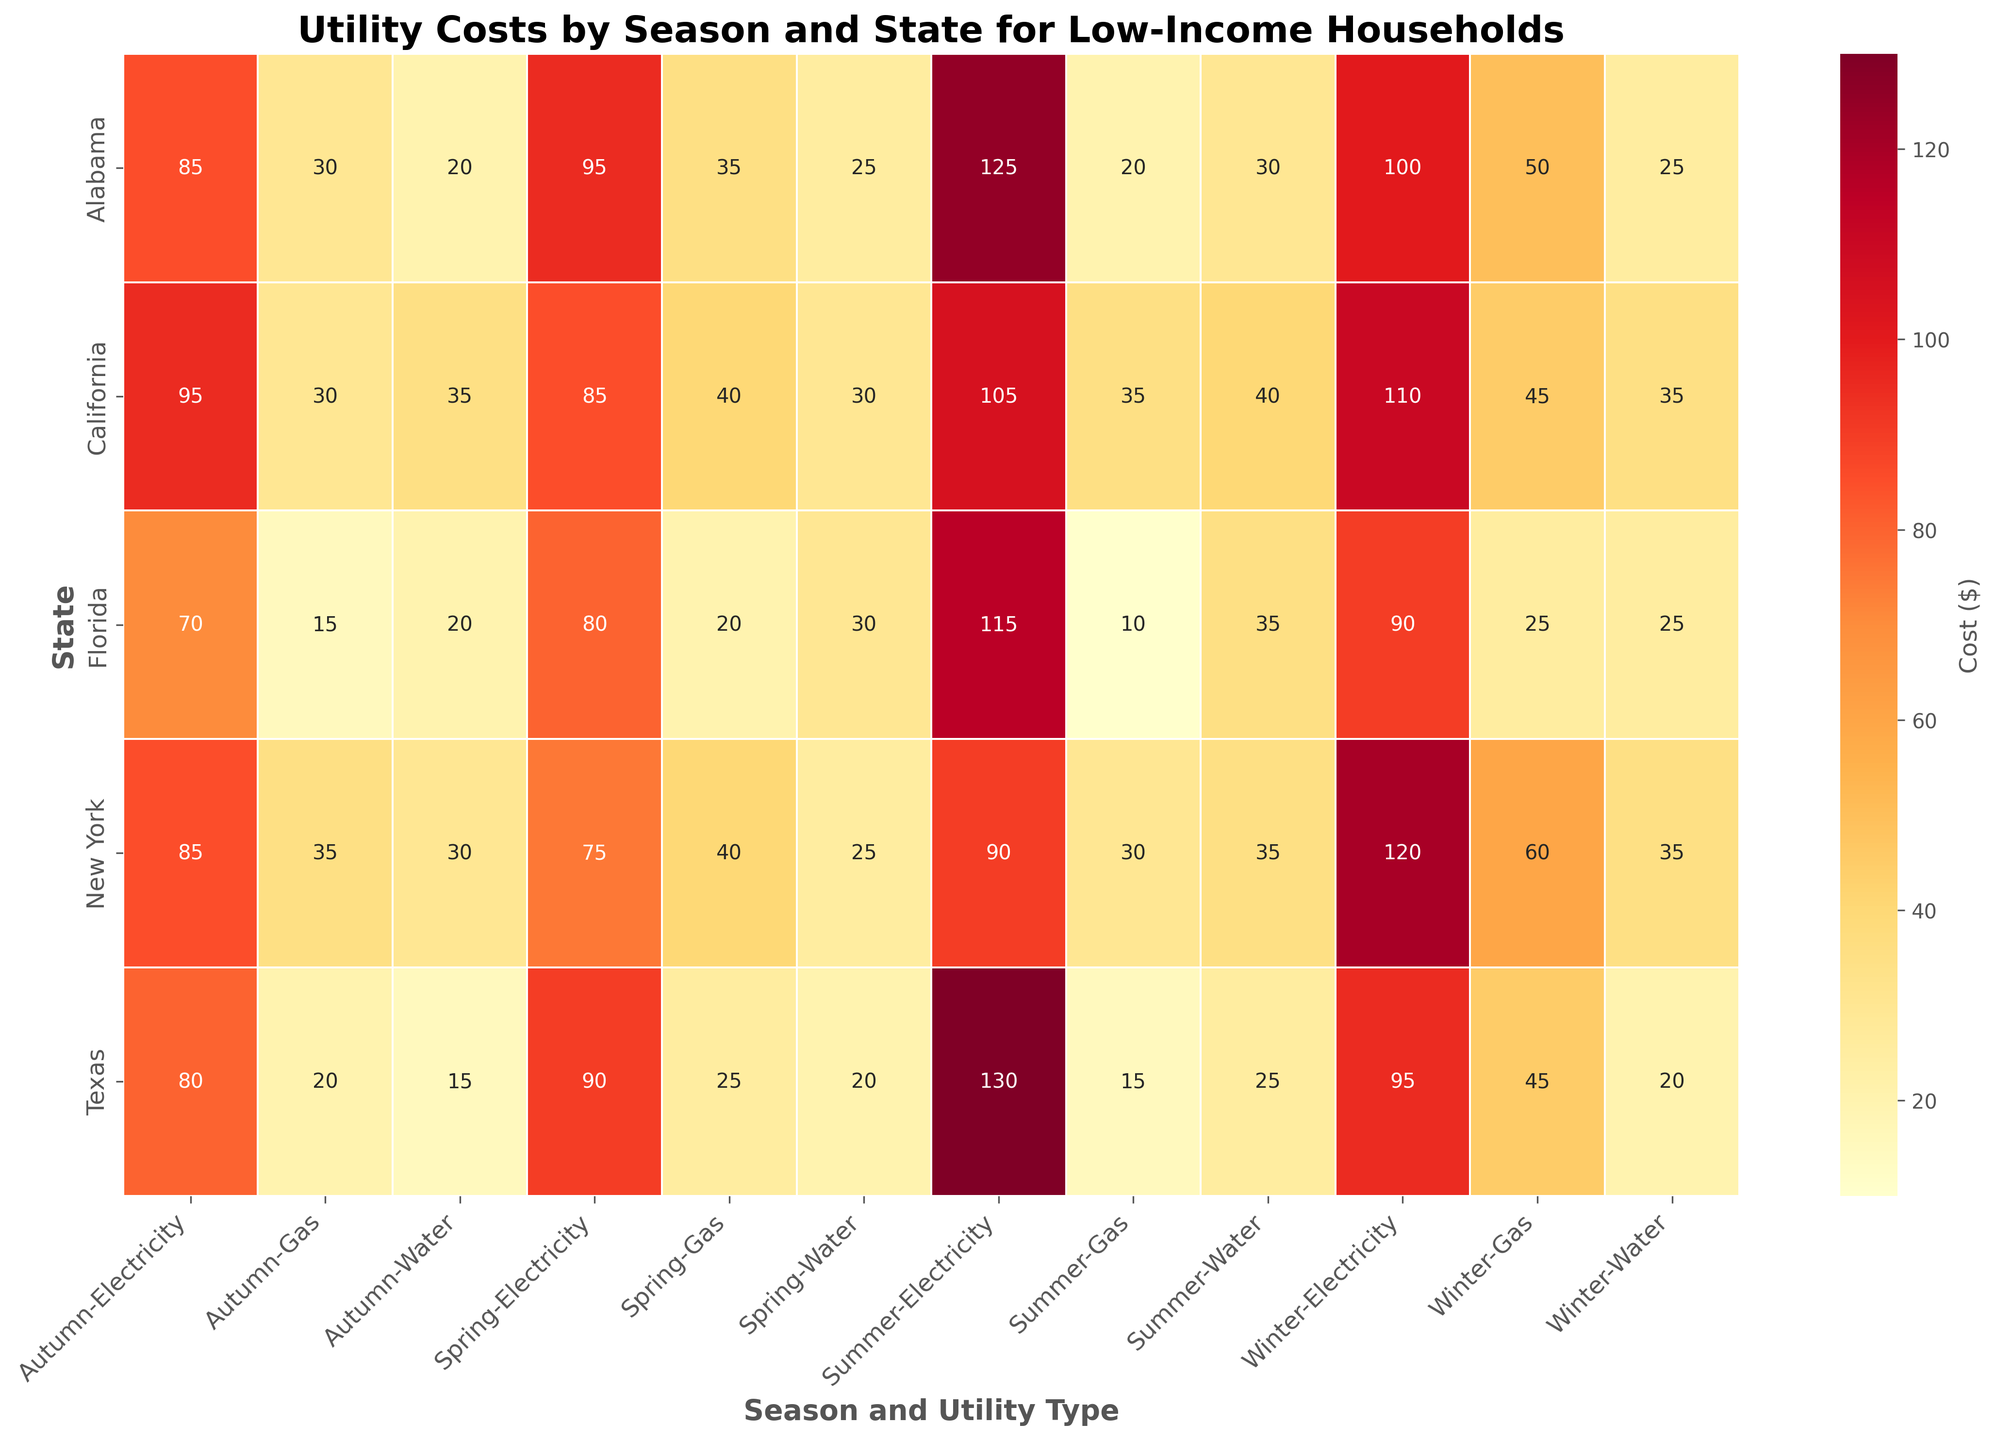What's the total utility cost for Alabama in the winter? Look at the intersection of Alabama and the Winter columns for all utility types (Electricity, Gas, Water). Sum these values: 100 (Electricity) + 50 (Gas) + 25 (Water) = 175.
Answer: 175 Which season has the highest electricity cost in Texas? Check the intersection of Texas and the four seasons for Electricity. Spring: 90, Summer: 130, Autumn: 80, Winter: 95. Summer has the highest electricity cost.
Answer: Summer Is the gas cost higher in New York or Florida during autumn? Compare the values at the intersection of Autumn and Gas for New York and Florida. New York: 35, Florida: 15. New York has the higher gas cost.
Answer: New York What's the average utility cost for Water across all seasons in California? Extract the Water costs for California in all seasons: 30 (Spring), 40 (Summer), 35 (Autumn), 35 (Winter). Average = (30 + 40 + 35 + 35) / 4 = 35.
Answer: 35 Which state has the lowest summer gas cost? Find the minimum value for Gas in Summer across all states. Alabama: 20, California: 35, Texas: 15, New York: 30, Florida: 10. Florida has the lowest summer gas cost.
Answer: Florida In which season is the utility cost for electricity and water combined highest in New York? Sum the electricity and water costs for each season in New York. 
- Spring: 75 + 25 = 100
- Summer: 90 + 35 = 125
- Autumn: 85 + 30 = 115
- Winter: 120 + 35 = 155
Winter has the highest combined cost.
Answer: Winter How much more does it cost for gas in Texas in the winter than in the summer? Subtract the summer gas cost from the winter gas cost in Texas. Winter: 45, Summer: 15. Difference = 45 - 15 = 30.
Answer: 30 What's the most expensive utility type for low-income households in Alabama during autumn? Identify the highest cost among the utilities in Alabama during autumn. Electricity: 85, Gas: 30, Water: 20. Electricity is the most expensive.
Answer: Electricity Which state has the highest spring water cost? Find the maximum value for Water in Spring across all states. Alabama: 25, California: 30, Texas: 20, New York: 25, Florida: 30. California and Florida both have the highest spring water cost at 30.
Answer: California and Florida What's the difference between the highest and lowest electricity costs across all states and seasons? Identify the highest and lowest electricity costs from all entries. Highest: Texas in Summer (130). Lowest: Florida in Autumn (70). Difference = 130 - 70 = 60.
Answer: 60 